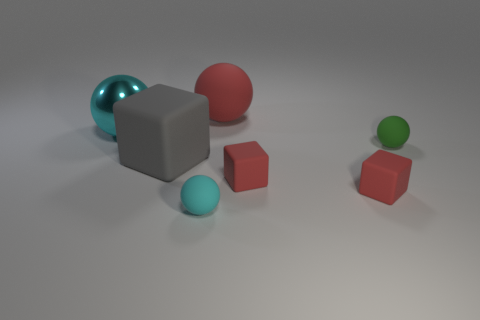What is the material of the cyan ball behind the small green ball?
Your response must be concise. Metal. There is another sphere that is the same color as the large metallic sphere; what is its size?
Keep it short and to the point. Small. There is a tiny matte sphere behind the small cyan matte sphere; does it have the same color as the matte object behind the shiny ball?
Give a very brief answer. No. What number of things are either big shiny balls or big balls?
Your answer should be very brief. 2. How many other things are there of the same shape as the big metal object?
Your response must be concise. 3. Is the object that is behind the large cyan object made of the same material as the cube that is on the left side of the red sphere?
Your answer should be very brief. Yes. What shape is the object that is behind the small green rubber thing and to the right of the small cyan thing?
Ensure brevity in your answer.  Sphere. Is there any other thing that has the same material as the red sphere?
Offer a terse response. Yes. There is a object that is to the left of the small cyan thing and in front of the green matte sphere; what material is it?
Offer a very short reply. Rubber. The tiny cyan thing that is the same material as the tiny green ball is what shape?
Make the answer very short. Sphere. 